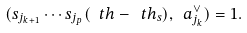<formula> <loc_0><loc_0><loc_500><loc_500>( s _ { j _ { k + 1 } } \cdots s _ { j _ { p } } ( \ t h - \ t h _ { s } ) , \ a _ { j _ { k } } ^ { \vee } ) = 1 .</formula> 